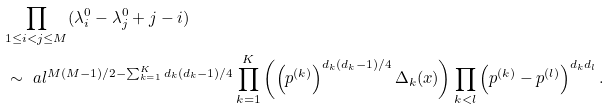Convert formula to latex. <formula><loc_0><loc_0><loc_500><loc_500>& \underset { 1 \leq i < j \leq M } { \prod } ( \lambda ^ { 0 } _ { i } - \lambda ^ { 0 } _ { j } + j - i ) \\ & \sim \ a l ^ { M ( M - 1 ) / 2 - \sum _ { k = 1 } ^ { K } d _ { k } ( d _ { k } - 1 ) / 4 } \prod _ { k = 1 } ^ { K } \left ( \left ( p ^ { ( k ) } \right ) ^ { d _ { k } ( d _ { k } - 1 ) / 4 } \Delta _ { k } ( x ) \right ) \prod _ { k < l } \left ( p ^ { ( k ) } - p ^ { ( l ) } \right ) ^ { d _ { k } d _ { l } } .</formula> 